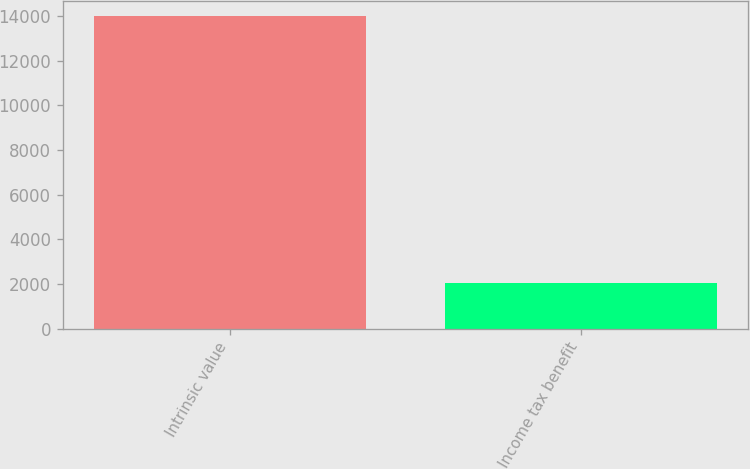Convert chart to OTSL. <chart><loc_0><loc_0><loc_500><loc_500><bar_chart><fcel>Intrinsic value<fcel>Income tax benefit<nl><fcel>13983<fcel>2049<nl></chart> 